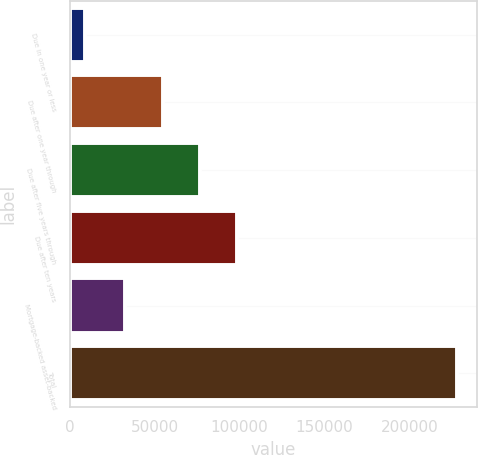Convert chart to OTSL. <chart><loc_0><loc_0><loc_500><loc_500><bar_chart><fcel>Due in one year or less<fcel>Due after one year through<fcel>Due after five years through<fcel>Due after ten years<fcel>Mortgage-backed asset-backed<fcel>Total<nl><fcel>9054<fcel>54803<fcel>76727.8<fcel>98652.6<fcel>32630<fcel>228302<nl></chart> 